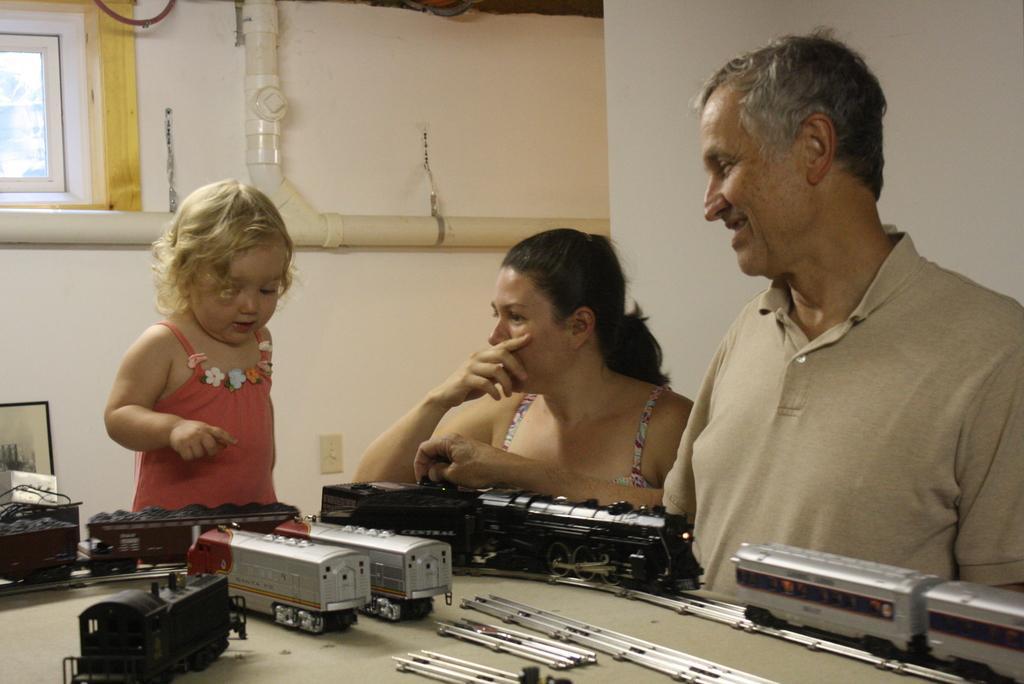Could you give a brief overview of what you see in this image? In this image, we can see a kid, woman and me. At the bottom, we can see train toys, some objects are placed on the surface. Background we can see a wall, pipes, glass window, photo frame and switchboard. 